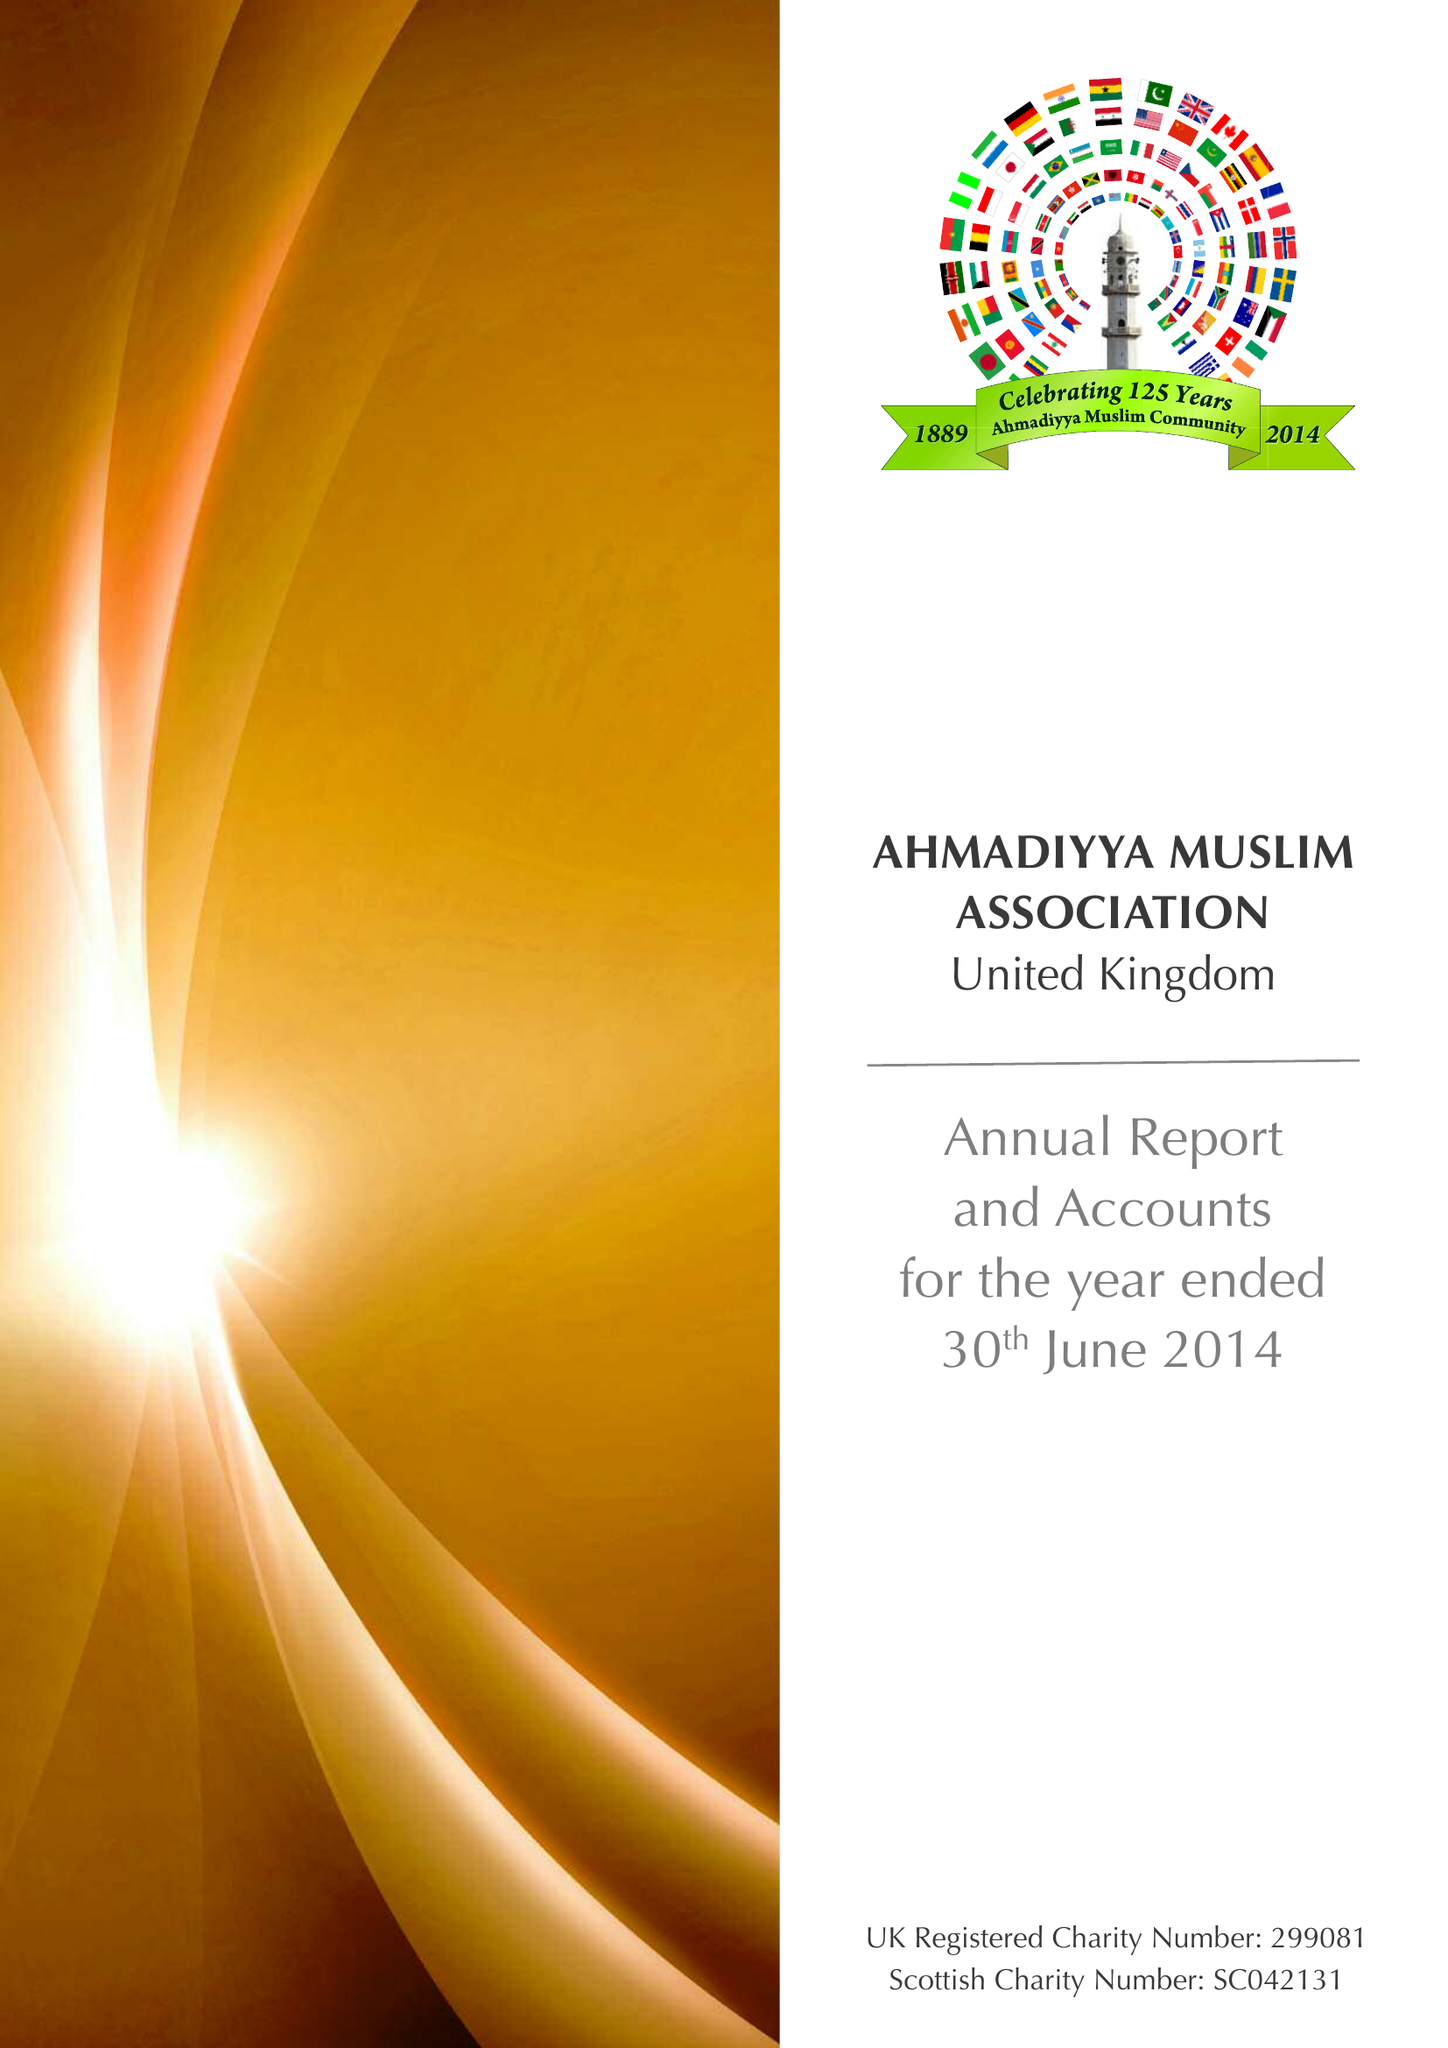What is the value for the spending_annually_in_british_pounds?
Answer the question using a single word or phrase. 11976715.00 